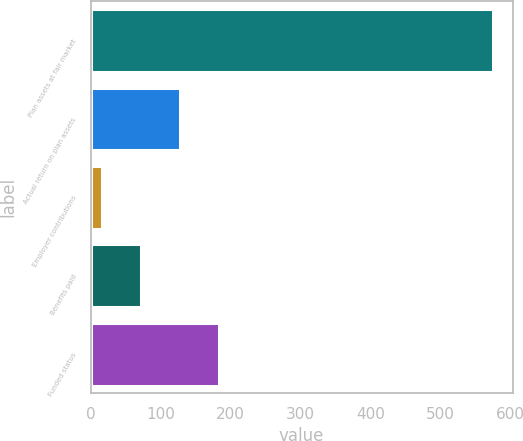<chart> <loc_0><loc_0><loc_500><loc_500><bar_chart><fcel>Plan assets at fair market<fcel>Actual return on plan assets<fcel>Employer contributions<fcel>Benefits paid<fcel>Funded status<nl><fcel>574.9<fcel>128.18<fcel>16.5<fcel>72.34<fcel>184.02<nl></chart> 